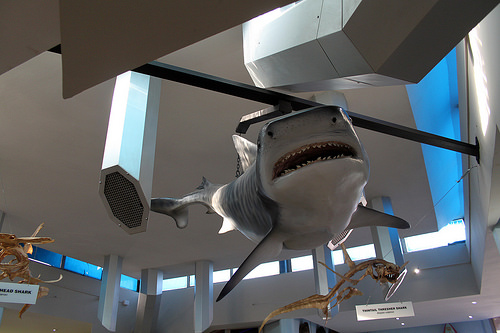<image>
Is the shark behind the vent? No. The shark is not behind the vent. From this viewpoint, the shark appears to be positioned elsewhere in the scene. 